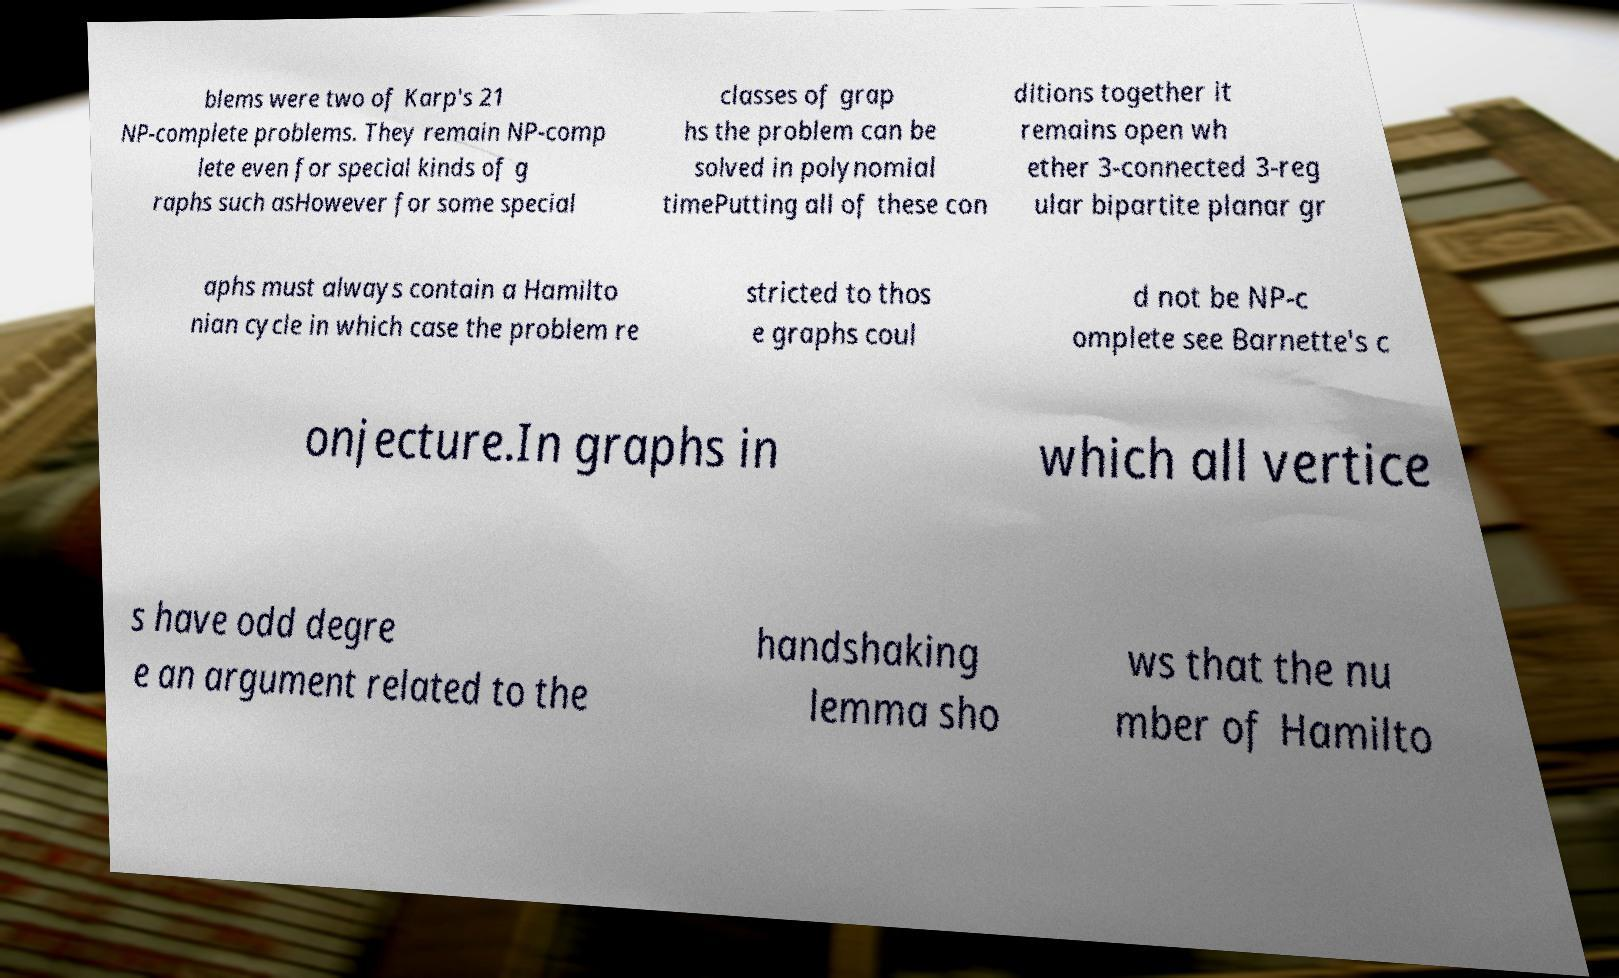Could you extract and type out the text from this image? blems were two of Karp's 21 NP-complete problems. They remain NP-comp lete even for special kinds of g raphs such asHowever for some special classes of grap hs the problem can be solved in polynomial timePutting all of these con ditions together it remains open wh ether 3-connected 3-reg ular bipartite planar gr aphs must always contain a Hamilto nian cycle in which case the problem re stricted to thos e graphs coul d not be NP-c omplete see Barnette's c onjecture.In graphs in which all vertice s have odd degre e an argument related to the handshaking lemma sho ws that the nu mber of Hamilto 